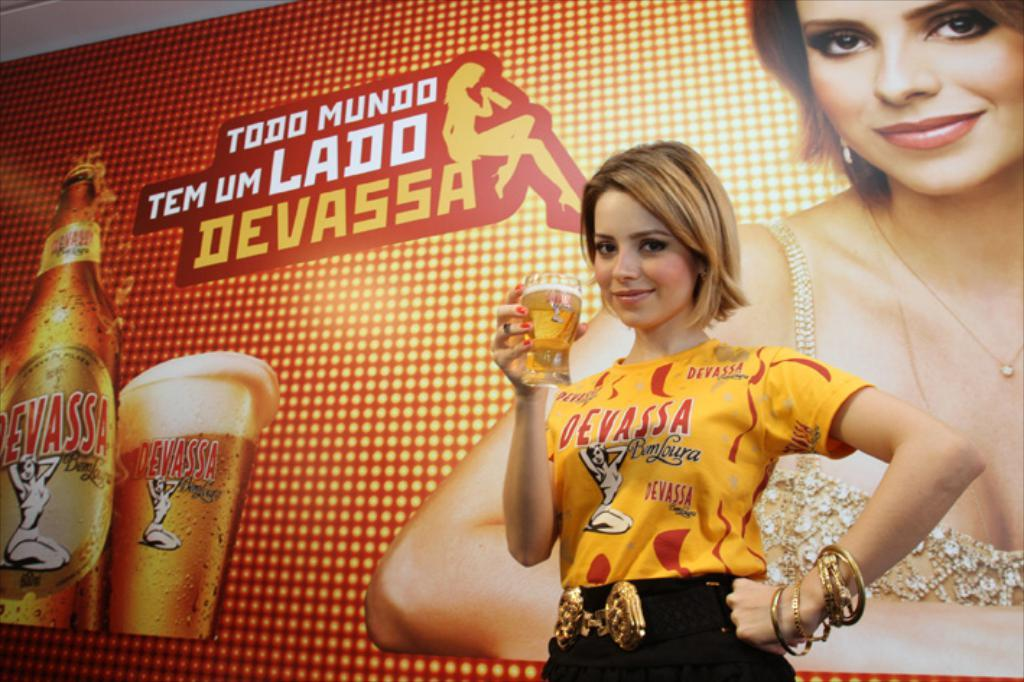<image>
Create a compact narrative representing the image presented. Devassa lager is being advertised by a pretty lady drinking a glassful, infront of a big banner devoted to her picture and the product. 